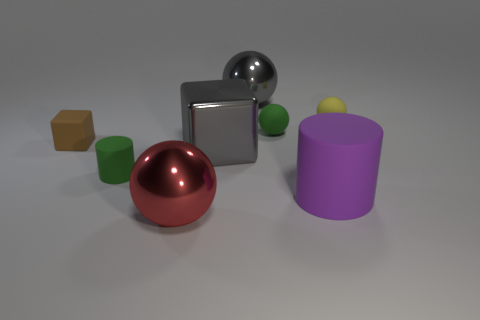There is a gray thing that is behind the matte cube; is it the same size as the big red thing?
Your response must be concise. Yes. How many shiny objects are either large gray blocks or red balls?
Your answer should be very brief. 2. How many small rubber cubes are in front of the tiny ball to the left of the purple thing?
Offer a terse response. 1. There is a metallic thing that is both right of the large red object and in front of the brown block; what is its shape?
Ensure brevity in your answer.  Cube. What is the material of the large object that is to the left of the big gray shiny thing on the left side of the large metallic sphere that is to the right of the red metal object?
Give a very brief answer. Metal. There is a thing that is the same color as the large block; what size is it?
Offer a very short reply. Large. What material is the large cube?
Your response must be concise. Metal. Does the tiny brown cube have the same material as the tiny object in front of the small brown block?
Ensure brevity in your answer.  Yes. What color is the small rubber object on the left side of the small cylinder that is on the left side of the large purple rubber cylinder?
Keep it short and to the point. Brown. There is a metallic object that is both in front of the small brown matte thing and behind the purple object; what is its size?
Provide a short and direct response. Large. 